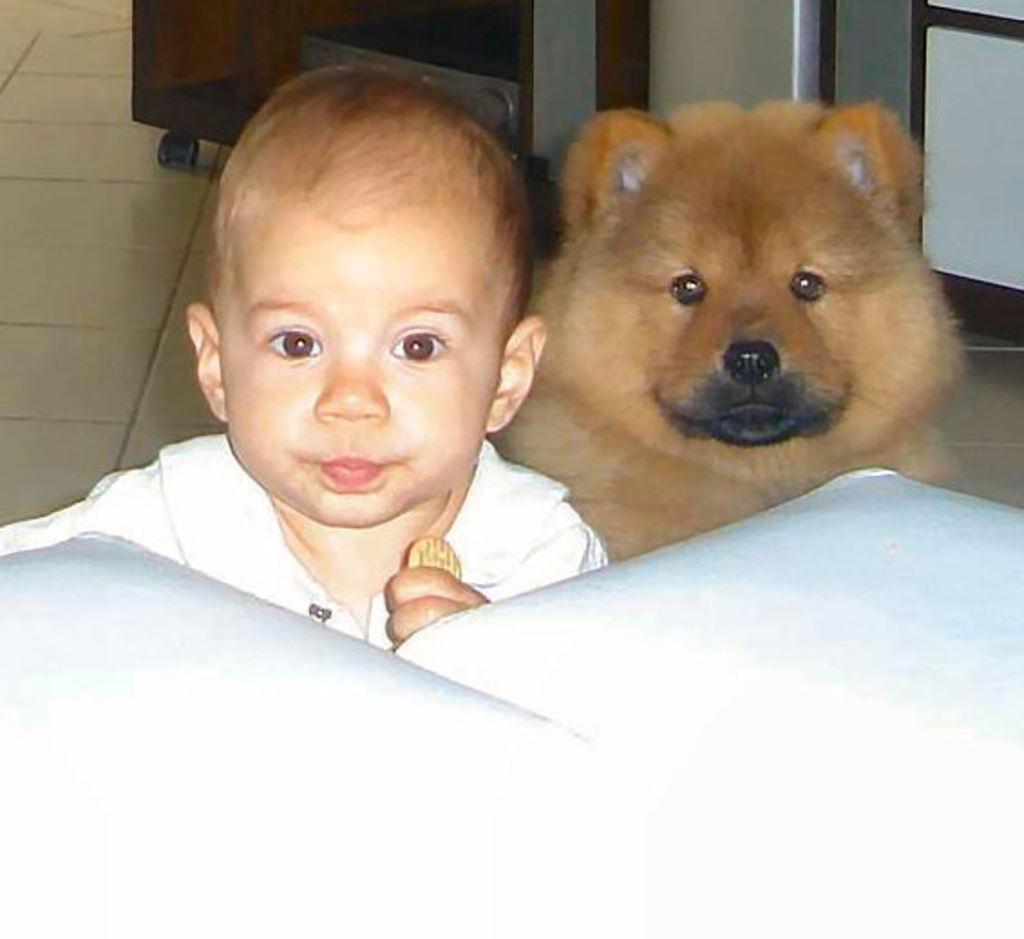Could you give a brief overview of what you see in this image? In this picture we can see a white object, boy, dog and in the background we can see some objects on the floor. 